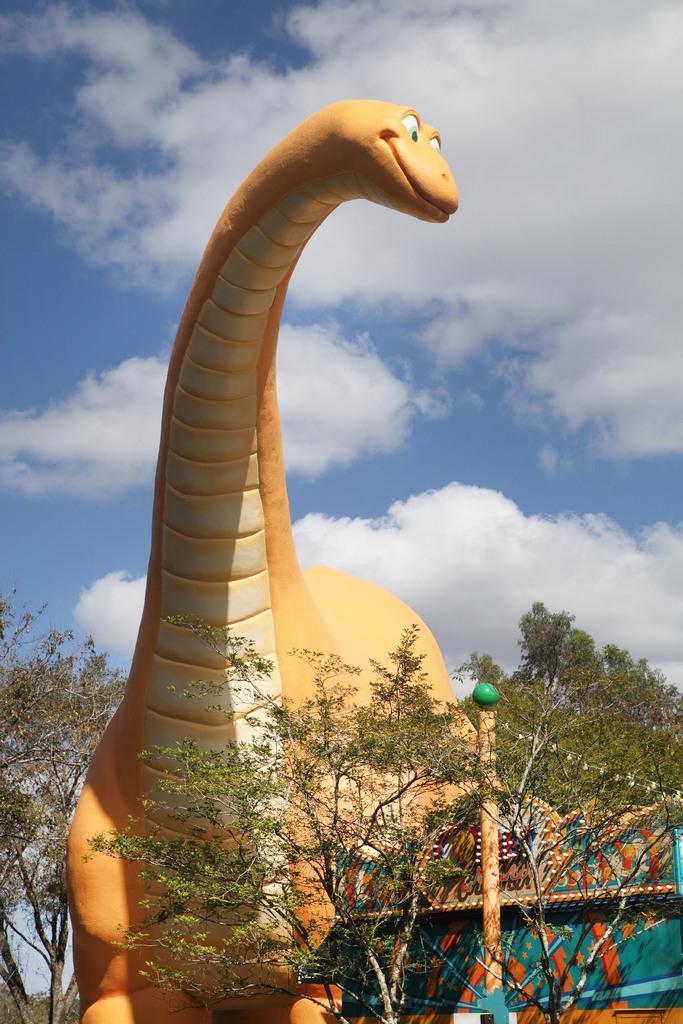Could you give a brief overview of what you see in this image? In this image, we can see a toy dinosaur. There are a few trees, plants, a pole. We can also see some objects on the bottom right. We can see the sky with clouds. 